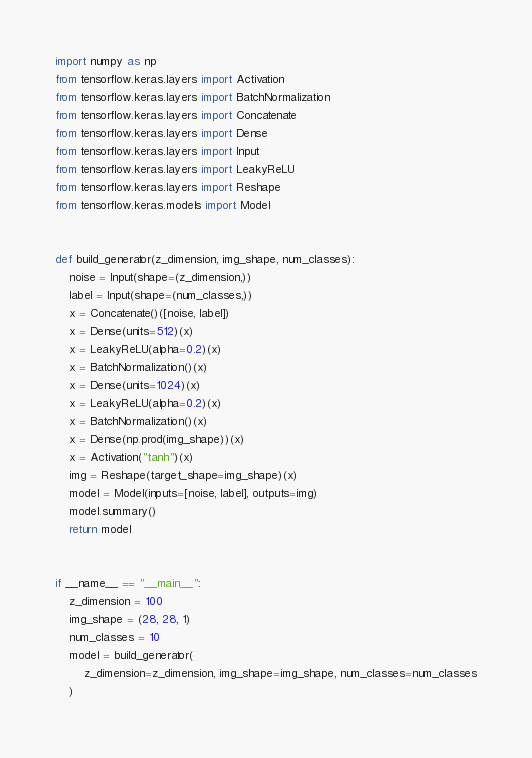<code> <loc_0><loc_0><loc_500><loc_500><_Python_>import numpy as np
from tensorflow.keras.layers import Activation
from tensorflow.keras.layers import BatchNormalization
from tensorflow.keras.layers import Concatenate
from tensorflow.keras.layers import Dense
from tensorflow.keras.layers import Input
from tensorflow.keras.layers import LeakyReLU
from tensorflow.keras.layers import Reshape
from tensorflow.keras.models import Model


def build_generator(z_dimension, img_shape, num_classes):
    noise = Input(shape=(z_dimension,))
    label = Input(shape=(num_classes,))
    x = Concatenate()([noise, label])
    x = Dense(units=512)(x)
    x = LeakyReLU(alpha=0.2)(x)
    x = BatchNormalization()(x)
    x = Dense(units=1024)(x)
    x = LeakyReLU(alpha=0.2)(x)
    x = BatchNormalization()(x)
    x = Dense(np.prod(img_shape))(x)
    x = Activation("tanh")(x)
    img = Reshape(target_shape=img_shape)(x)
    model = Model(inputs=[noise, label], outputs=img)
    model.summary()
    return model


if __name__ == "__main__":
    z_dimension = 100
    img_shape = (28, 28, 1)
    num_classes = 10
    model = build_generator(
        z_dimension=z_dimension, img_shape=img_shape, num_classes=num_classes
    )
</code> 